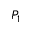Convert formula to latex. <formula><loc_0><loc_0><loc_500><loc_500>P _ { 1 }</formula> 